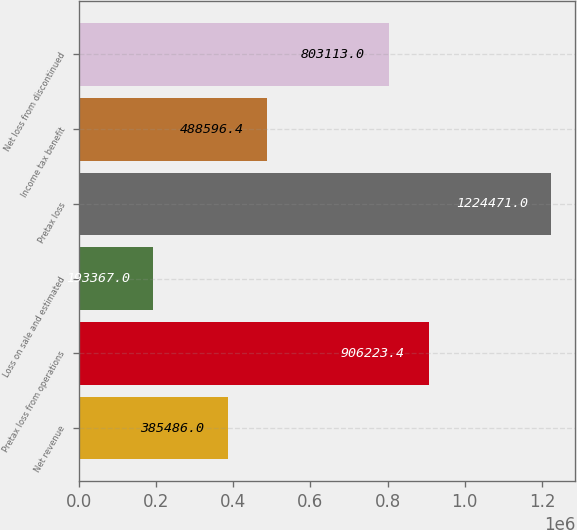Convert chart to OTSL. <chart><loc_0><loc_0><loc_500><loc_500><bar_chart><fcel>Net revenue<fcel>Pretax loss from operations<fcel>Loss on sale and estimated<fcel>Pretax loss<fcel>Income tax benefit<fcel>Net loss from discontinued<nl><fcel>385486<fcel>906223<fcel>193367<fcel>1.22447e+06<fcel>488596<fcel>803113<nl></chart> 